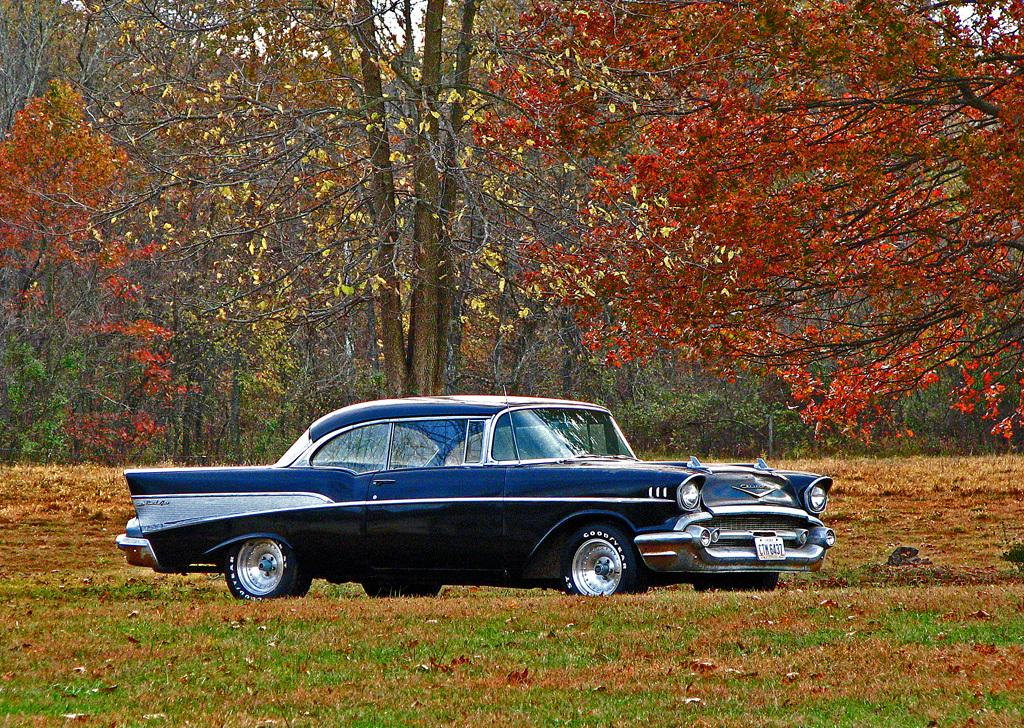What type of vehicle is in the image? There is a blue car in the image. What colors are the flowers in the image? The flowers in the image are red, orange, brown, and yellow. What type of vegetation is present in the image? There are trees in the image. Where is the head of the car located in the image? The car in the image does not have a head, as it is a vehicle and not a living being. 